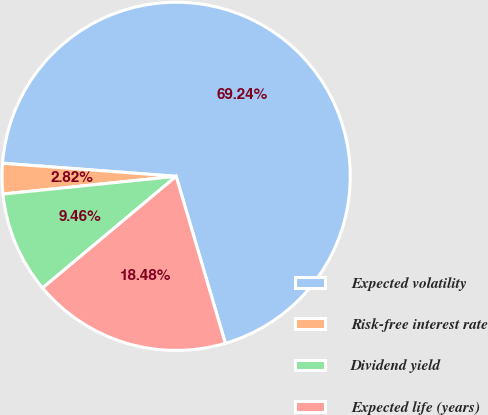Convert chart. <chart><loc_0><loc_0><loc_500><loc_500><pie_chart><fcel>Expected volatility<fcel>Risk-free interest rate<fcel>Dividend yield<fcel>Expected life (years)<nl><fcel>69.24%<fcel>2.82%<fcel>9.46%<fcel>18.48%<nl></chart> 